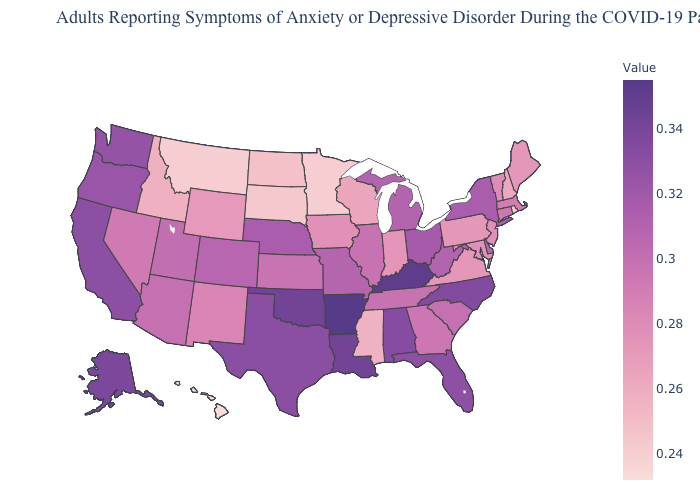Does Connecticut have the lowest value in the USA?
Give a very brief answer. No. Which states hav the highest value in the MidWest?
Give a very brief answer. Ohio. Does the map have missing data?
Be succinct. No. Does Alaska have the highest value in the West?
Answer briefly. Yes. Among the states that border Vermont , which have the lowest value?
Give a very brief answer. New Hampshire. 